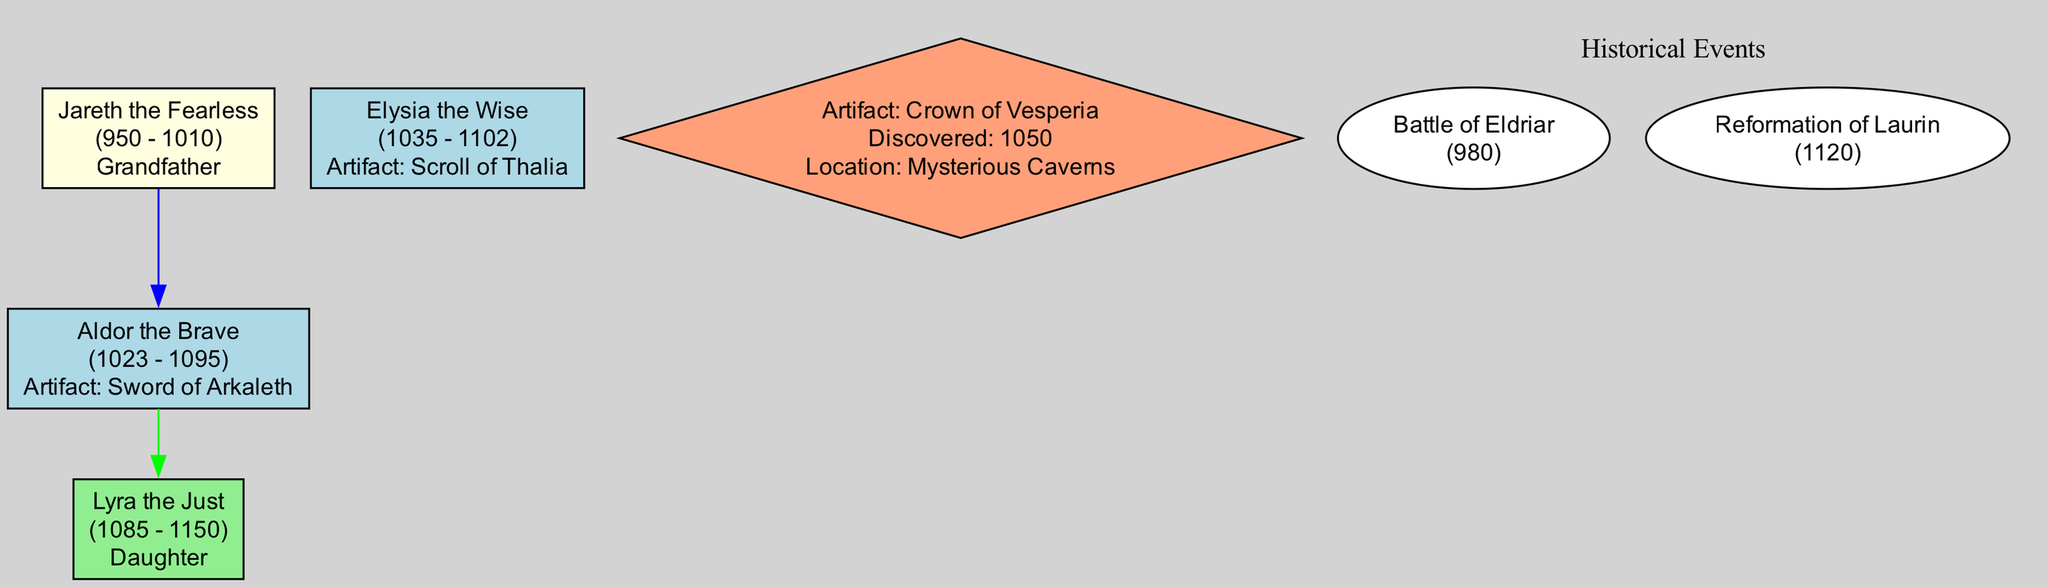What year was Aldor the Brave born? The diagram states that Aldor the Brave was born in 1023, as indicated in the information about his life.
Answer: 1023 How many artifacts are associated with Elysia the Wise? Upon examining Elysia the Wise's details, there is one artifact listed, which is the Scroll of Thalia.
Answer: 1 What is the relationship between Jareth the Fearless and Aldor the Brave? The diagram shows that Jareth the Fearless is labeled as Aldor's grandfather, indicating a direct familial relationship.
Answer: Grandfather What significant battle did Jareth the Fearless participate in? The historical event mentioned for Jareth is the Battle of Eldriar, described as a significant battle shaping the kingdom's future.
Answer: Battle of Eldriar What historical event is associated with Lyra the Just? The diagram lists the Reformation of Laurin as the major societal reform led by Lyra, indicating her impact on society.
Answer: Reformation of Laurin Which artifact was discovered in the Ancient Ruins of Arkaleth? The Sword of Arkaleth is specifically noted to have been discovered at the Ancient Ruins of Arkaleth in the hero Aldor the Brave's section.
Answer: Sword of Arkaleth Who are the descendants of Aldor the Brave? The diagram identifies Lyra the Just as the daughter of Aldor the Brave, indicating her lineage in the family tree.
Answer: Lyra the Just In what year was the Scroll of Thalia discovered? The diagram states that the Scroll of Thalia was discovered in 1090, as part of the information regarding Elysia the Wise.
Answer: 1090 What color represents historical events in the diagram? The diagram groups historical events in an oval shape filled with white color, showcasing them as a separate category within the family tree context.
Answer: White 